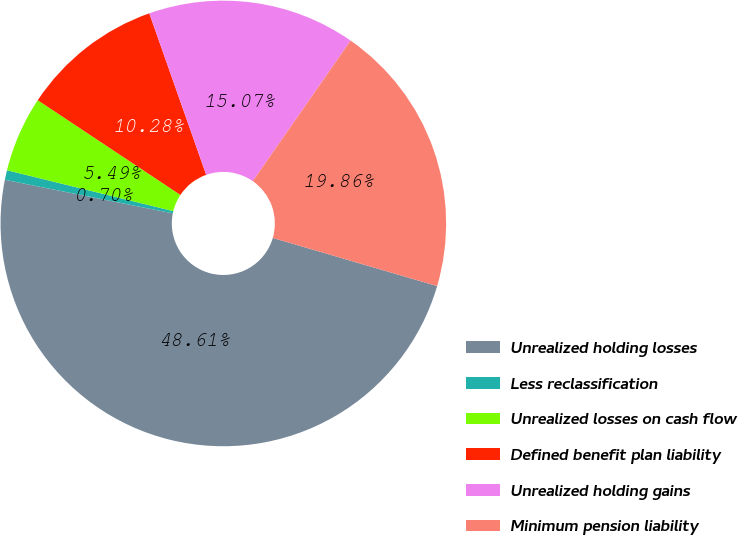Convert chart. <chart><loc_0><loc_0><loc_500><loc_500><pie_chart><fcel>Unrealized holding losses<fcel>Less reclassification<fcel>Unrealized losses on cash flow<fcel>Defined benefit plan liability<fcel>Unrealized holding gains<fcel>Minimum pension liability<nl><fcel>48.61%<fcel>0.7%<fcel>5.49%<fcel>10.28%<fcel>15.07%<fcel>19.86%<nl></chart> 